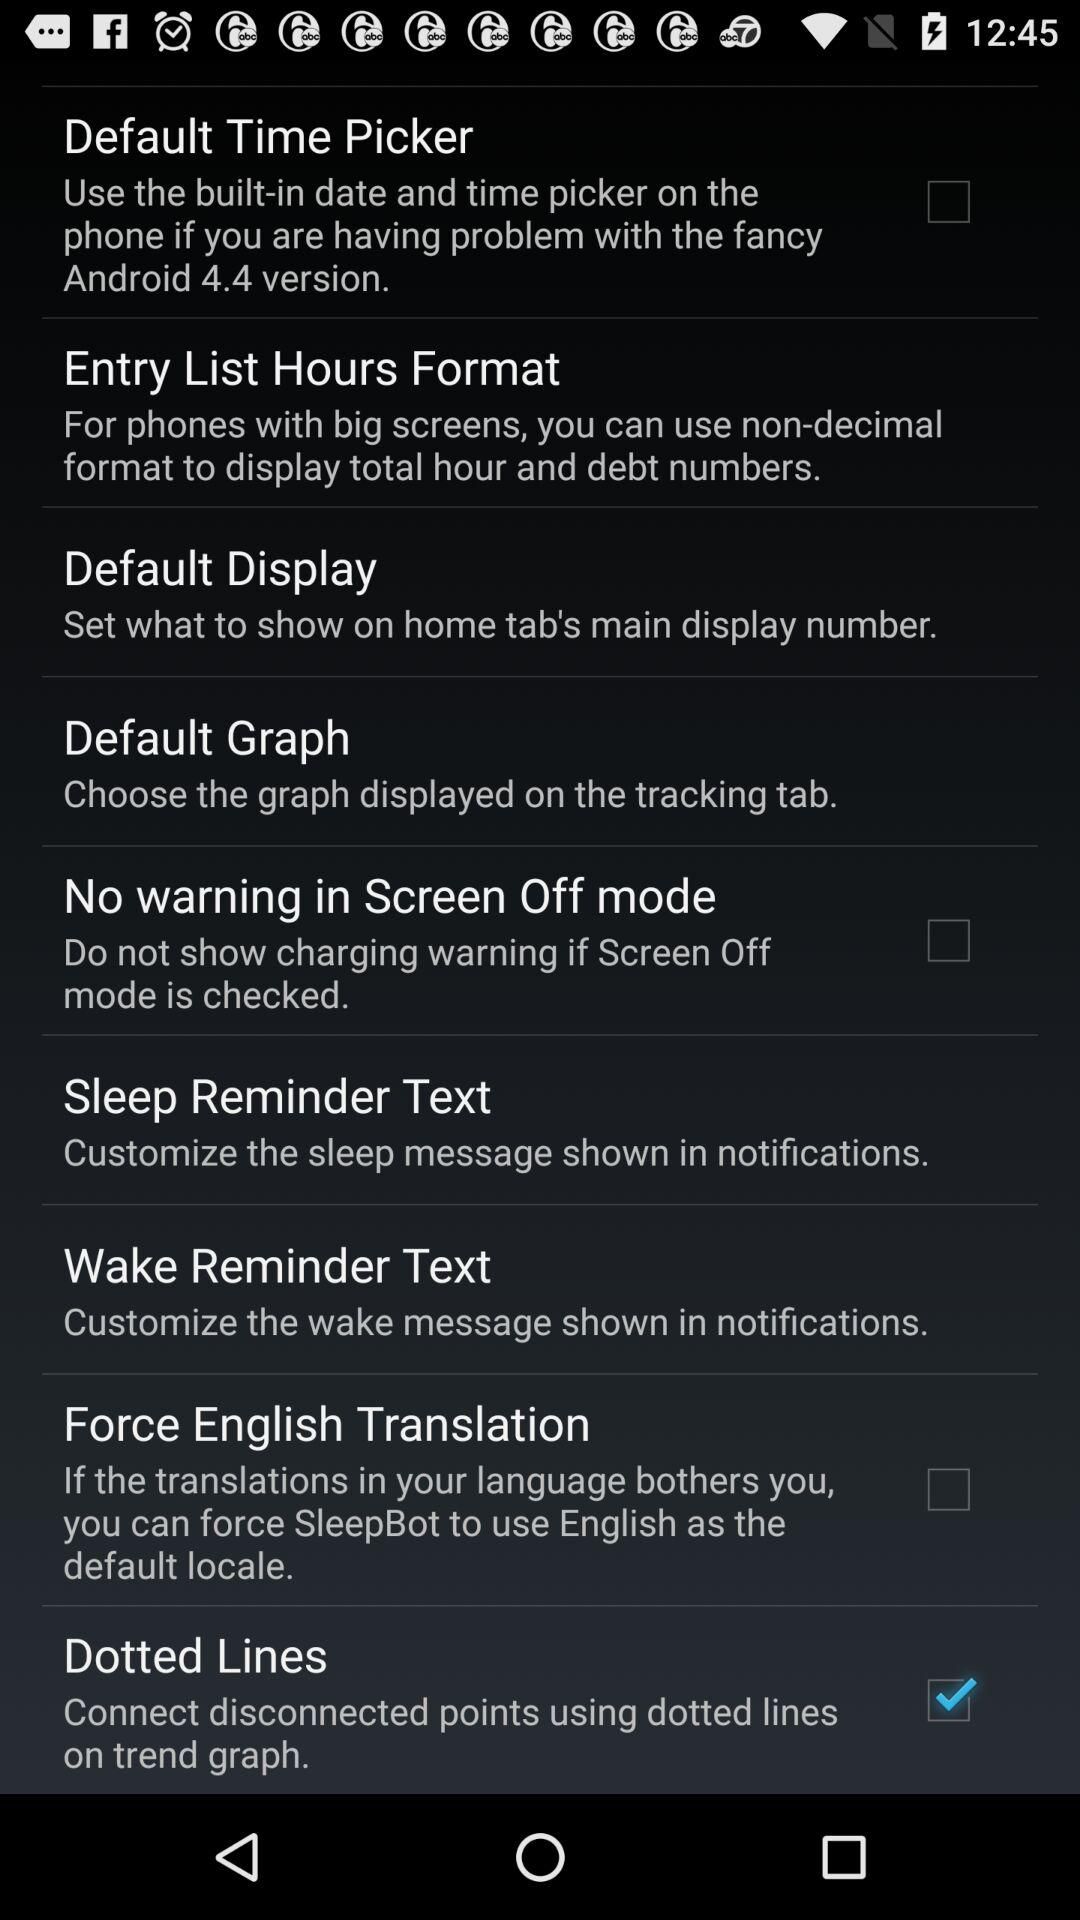What is the status of the "Dotted Lines"? The status is "on". 